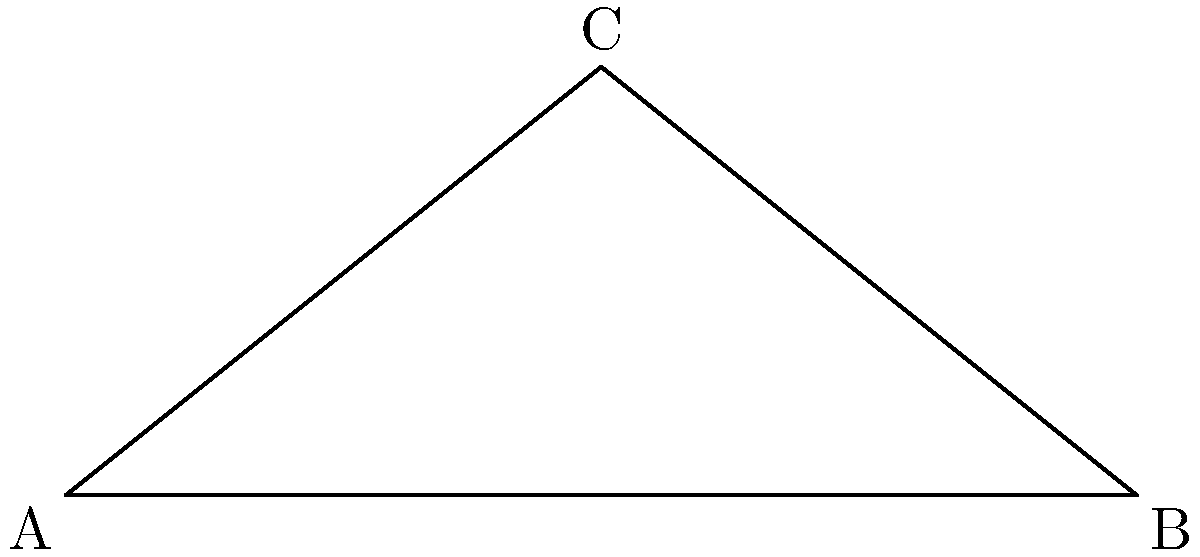As a delivery business owner, you're trying to optimize your route over a hilly road. The road forms a right triangle, with a horizontal distance of 500 meters and a vertical rise of $h$ meters. The angle at the base of the hill is 30°. To minimize fuel consumption, you need to find the optimal angle $x$ for your delivery vehicles to climb. What is the value of $x$ in degrees? Let's approach this step-by-step:

1) In a right triangle, the sum of all angles is 180°. We know one angle is 90° (the right angle) and another is 30°.

2) Let's call the angle we're looking for $x$. We can set up an equation:

   $90° + 30° + x° = 180°$

3) Simplify:
   $120° + x° = 180°$

4) Solve for $x$:
   $x° = 180° - 120° = 60°$

5) We can verify this using trigonometry. In a 30-60-90 triangle:
   - The shortest side (opposite to 30°) is $\frac{1}{2}$ the hypotenuse
   - The side opposite to 60° is $\frac{\sqrt{3}}{2}$ times the hypotenuse
   - The longest side (hypotenuse) is twice the shortest side

6) In our case, the shortest side (base of the triangle) is 500 m, so:
   - Hypotenuse = 1000 m
   - Height ($h$) = $500\sqrt{3}$ m ≈ 866 m

This confirms that the angle opposite to the 500 m side is indeed 30°, and the angle opposite to the height is 60°.
Answer: 60° 